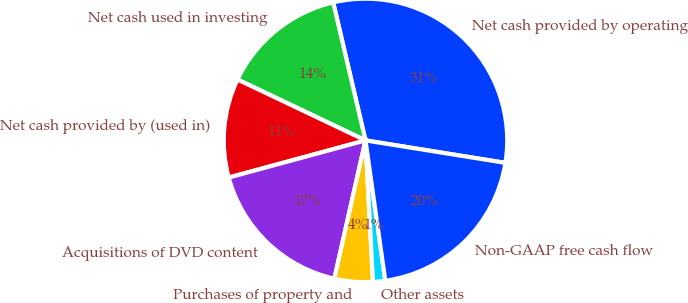<chart> <loc_0><loc_0><loc_500><loc_500><pie_chart><fcel>Net cash provided by operating<fcel>Net cash used in investing<fcel>Net cash provided by (used in)<fcel>Acquisitions of DVD content<fcel>Purchases of property and<fcel>Other assets<fcel>Non-GAAP free cash flow<nl><fcel>31.19%<fcel>14.27%<fcel>11.29%<fcel>17.25%<fcel>4.37%<fcel>1.39%<fcel>20.23%<nl></chart> 